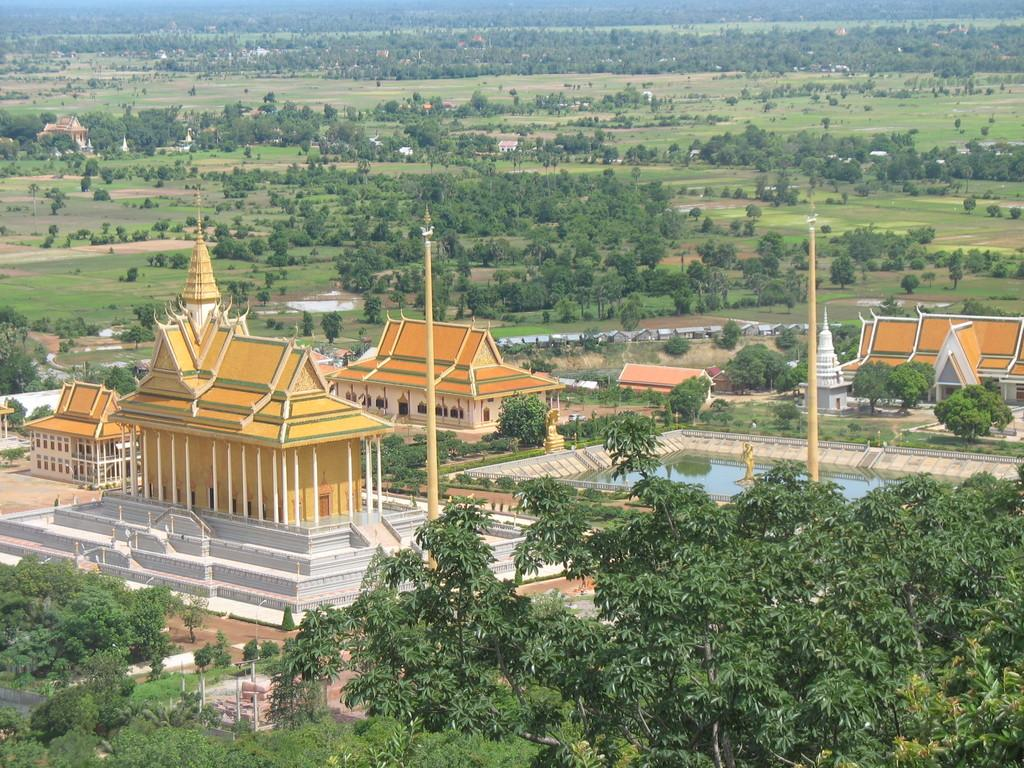What type of architecture can be seen in the image? There is ancient architecture in the image. What structures are present in the image besides the ancient architecture? There are poles, houses, and trees visible in the image. What natural elements can be seen in the image? Water, trees, and plants are visible in the image. What is the ground like in the image? The ground is visible in the image. What type of rod can be seen in the image? There is no rod present in the image. Is there a gun visible in the image? No, there is no gun present in the image. Can you see a basketball in the image? There is no basketball present in the image. 